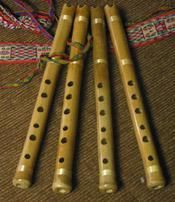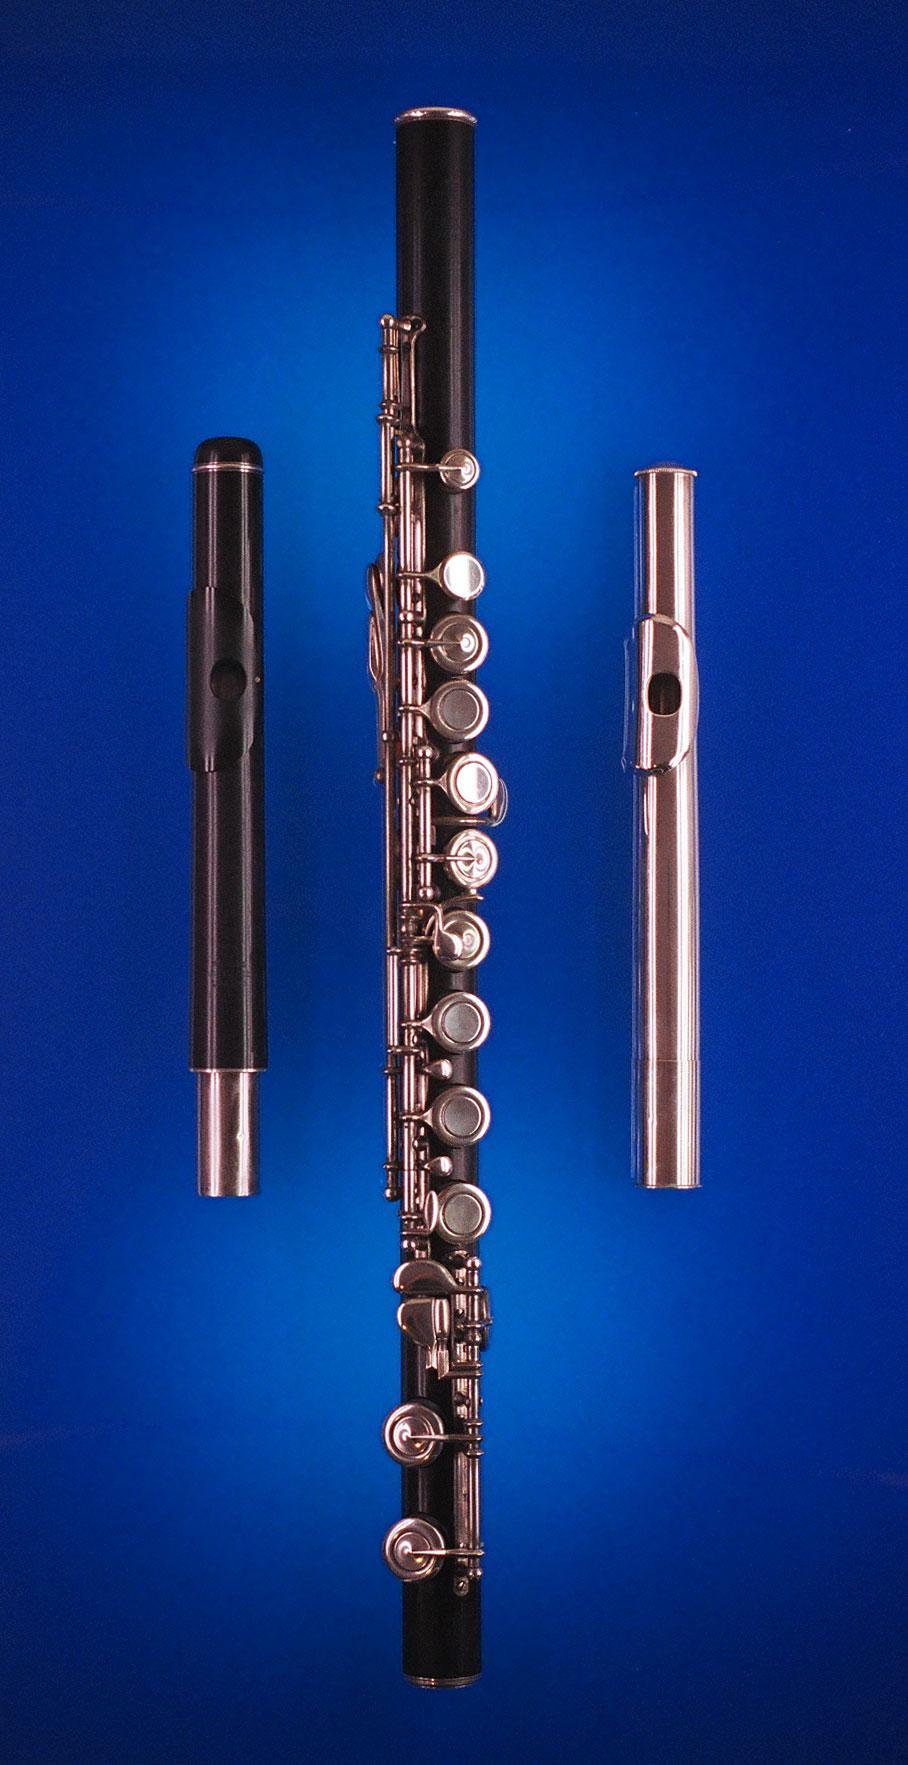The first image is the image on the left, the second image is the image on the right. Analyze the images presented: Is the assertion "One image contains exactly four wooden flutes displayed in a row, with cords at their tops." valid? Answer yes or no. Yes. The first image is the image on the left, the second image is the image on the right. For the images displayed, is the sentence "The background of one of the images is blue." factually correct? Answer yes or no. Yes. 